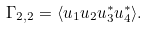Convert formula to latex. <formula><loc_0><loc_0><loc_500><loc_500>\Gamma _ { 2 , 2 } = \langle u _ { 1 } u _ { 2 } u _ { 3 } ^ { \ast } u _ { 4 } ^ { \ast } \rangle .</formula> 